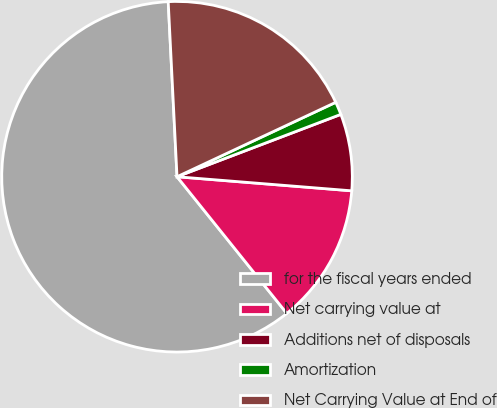Convert chart. <chart><loc_0><loc_0><loc_500><loc_500><pie_chart><fcel>for the fiscal years ended<fcel>Net carrying value at<fcel>Additions net of disposals<fcel>Amortization<fcel>Net Carrying Value at End of<nl><fcel>59.97%<fcel>12.95%<fcel>7.07%<fcel>1.19%<fcel>18.82%<nl></chart> 